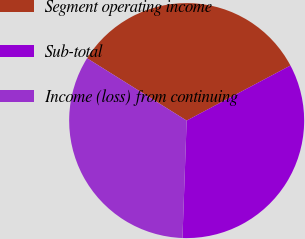Convert chart. <chart><loc_0><loc_0><loc_500><loc_500><pie_chart><fcel>Segment operating income<fcel>Sub-total<fcel>Income (loss) from continuing<nl><fcel>33.33%<fcel>33.33%<fcel>33.33%<nl></chart> 